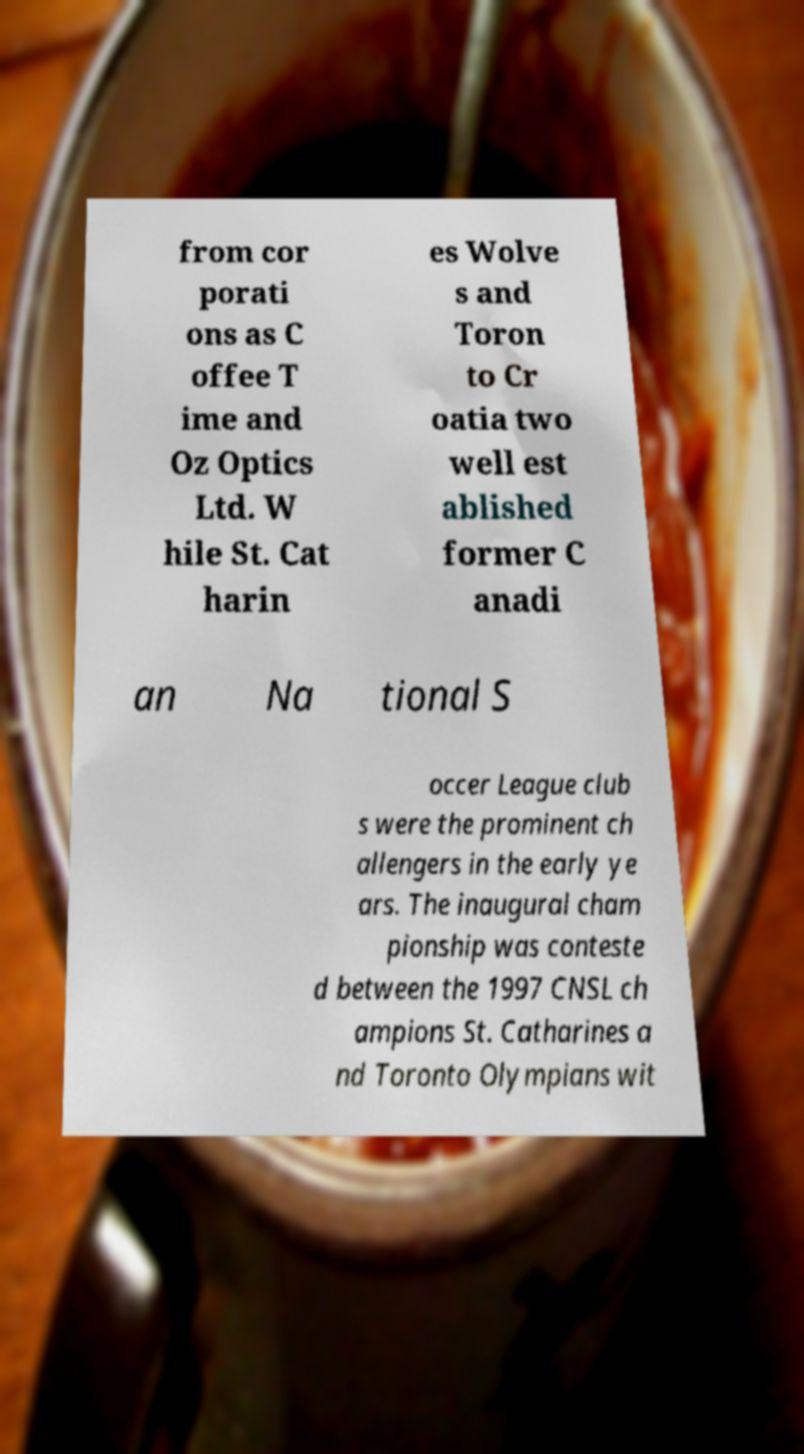I need the written content from this picture converted into text. Can you do that? from cor porati ons as C offee T ime and Oz Optics Ltd. W hile St. Cat harin es Wolve s and Toron to Cr oatia two well est ablished former C anadi an Na tional S occer League club s were the prominent ch allengers in the early ye ars. The inaugural cham pionship was conteste d between the 1997 CNSL ch ampions St. Catharines a nd Toronto Olympians wit 